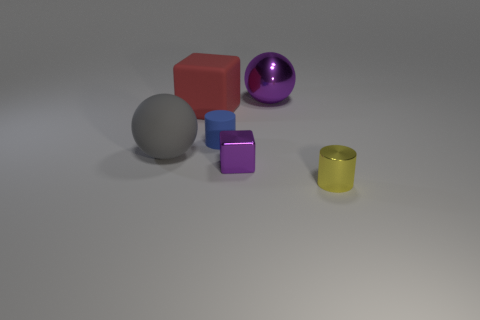How many gray things are either large matte blocks or big rubber spheres?
Your answer should be compact. 1. There is a big ball left of the blue rubber cylinder; what is it made of?
Give a very brief answer. Rubber. Do the tiny cylinder that is to the left of the tiny yellow shiny object and the purple cube have the same material?
Ensure brevity in your answer.  No. What shape is the yellow object?
Provide a succinct answer. Cylinder. What number of small purple objects are in front of the big matte object that is in front of the tiny cylinder that is behind the tiny yellow thing?
Provide a succinct answer. 1. How many other things are there of the same material as the small blue thing?
Offer a terse response. 2. What material is the yellow thing that is the same size as the blue object?
Offer a terse response. Metal. Do the small cylinder that is behind the purple metal block and the large ball to the right of the purple block have the same color?
Keep it short and to the point. No. Is there a cyan metallic thing of the same shape as the tiny purple thing?
Your response must be concise. No. What shape is the yellow shiny thing that is the same size as the blue matte cylinder?
Offer a very short reply. Cylinder. 